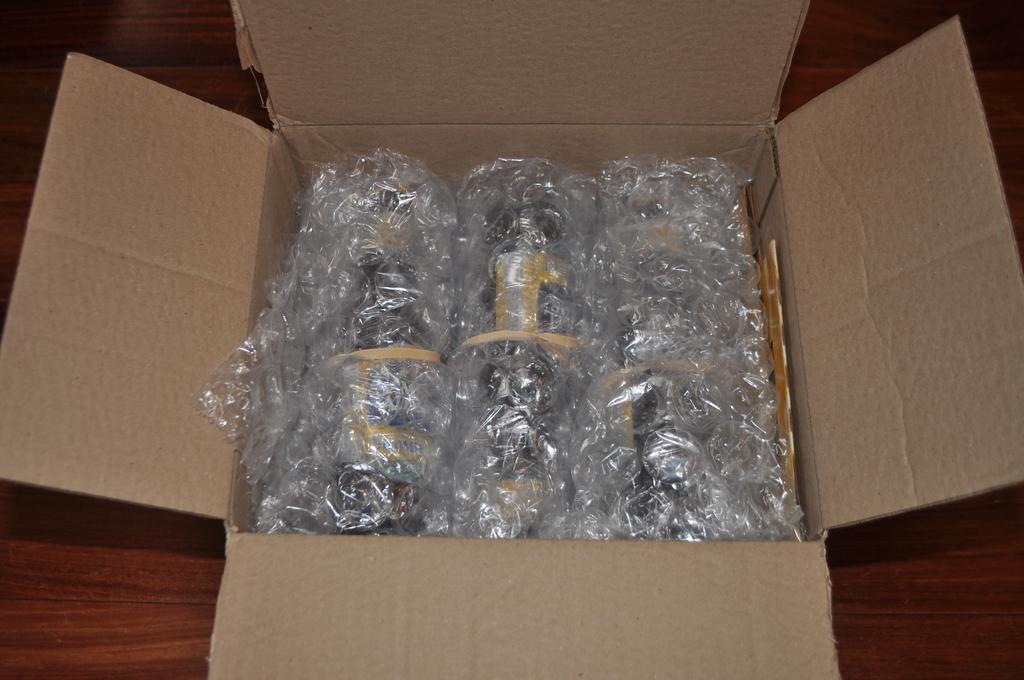Describe this image in one or two sentences. In the picture we can see a wooden plank on it, we can see a cardboard box which is opened and in it we can see some things are placed with some polythene covers. 